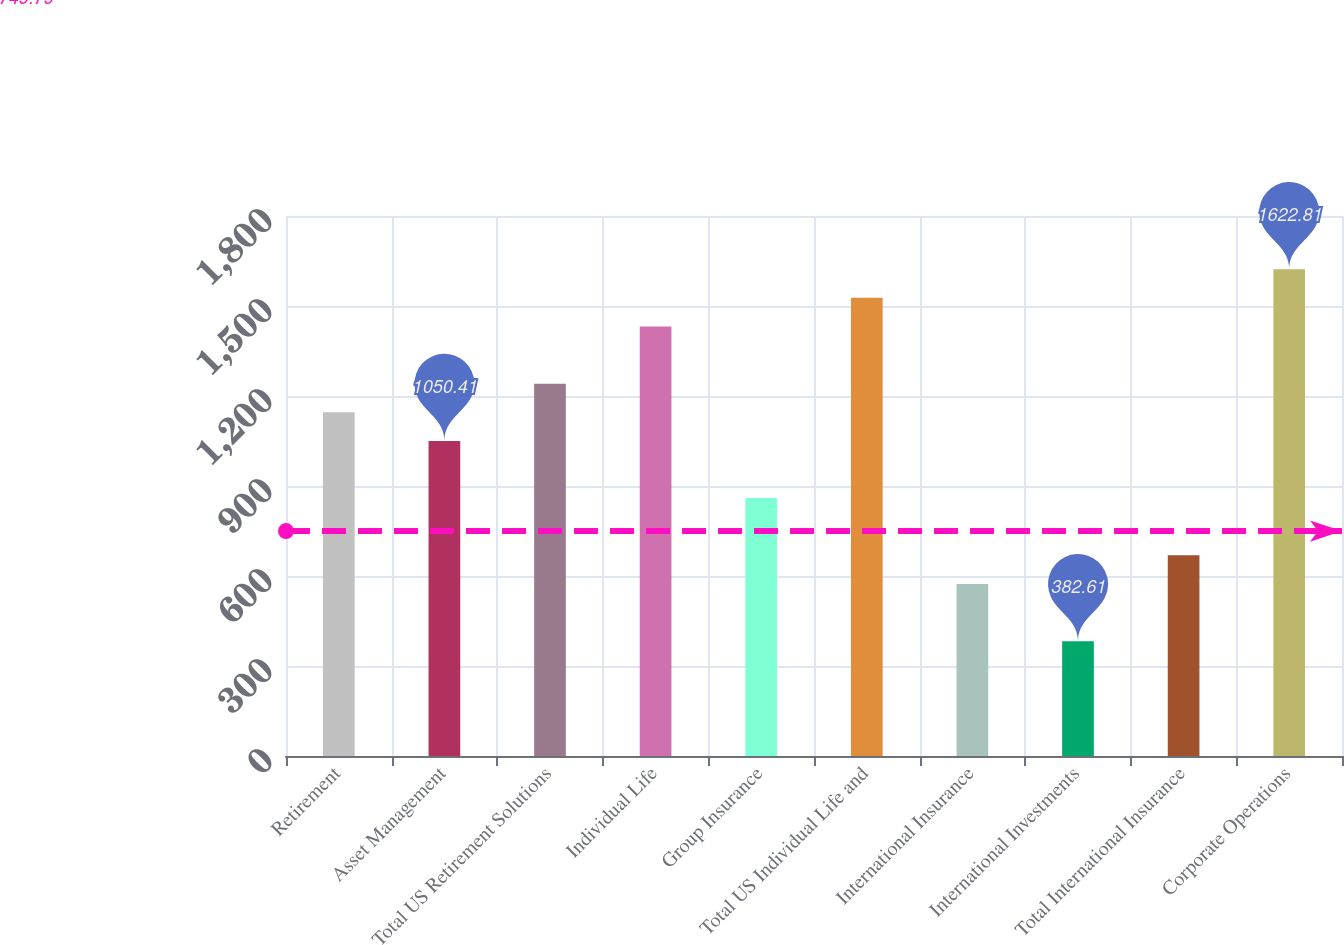Convert chart to OTSL. <chart><loc_0><loc_0><loc_500><loc_500><bar_chart><fcel>Retirement<fcel>Asset Management<fcel>Total US Retirement Solutions<fcel>Individual Life<fcel>Group Insurance<fcel>Total US Individual Life and<fcel>International Insurance<fcel>International Investments<fcel>Total International Insurance<fcel>Corporate Operations<nl><fcel>1145.81<fcel>1050.41<fcel>1241.21<fcel>1432.01<fcel>859.61<fcel>1527.41<fcel>573.41<fcel>382.61<fcel>668.81<fcel>1622.81<nl></chart> 